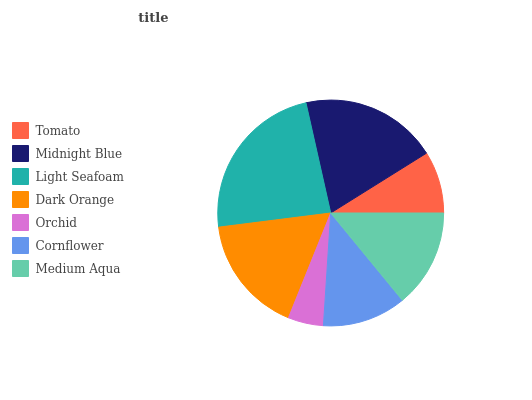Is Orchid the minimum?
Answer yes or no. Yes. Is Light Seafoam the maximum?
Answer yes or no. Yes. Is Midnight Blue the minimum?
Answer yes or no. No. Is Midnight Blue the maximum?
Answer yes or no. No. Is Midnight Blue greater than Tomato?
Answer yes or no. Yes. Is Tomato less than Midnight Blue?
Answer yes or no. Yes. Is Tomato greater than Midnight Blue?
Answer yes or no. No. Is Midnight Blue less than Tomato?
Answer yes or no. No. Is Medium Aqua the high median?
Answer yes or no. Yes. Is Medium Aqua the low median?
Answer yes or no. Yes. Is Light Seafoam the high median?
Answer yes or no. No. Is Cornflower the low median?
Answer yes or no. No. 